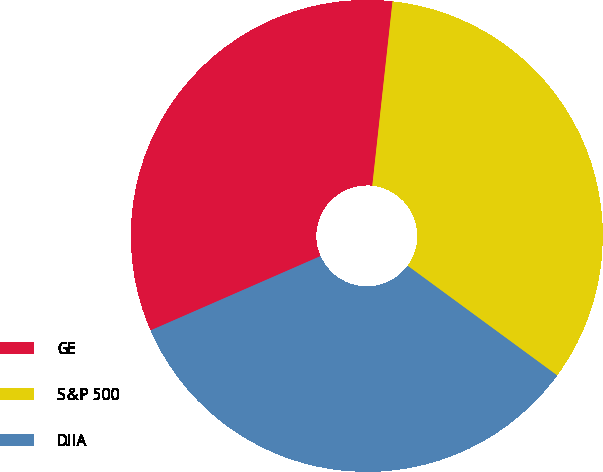Convert chart. <chart><loc_0><loc_0><loc_500><loc_500><pie_chart><fcel>GE<fcel>S&P 500<fcel>DJIA<nl><fcel>33.3%<fcel>33.33%<fcel>33.37%<nl></chart> 